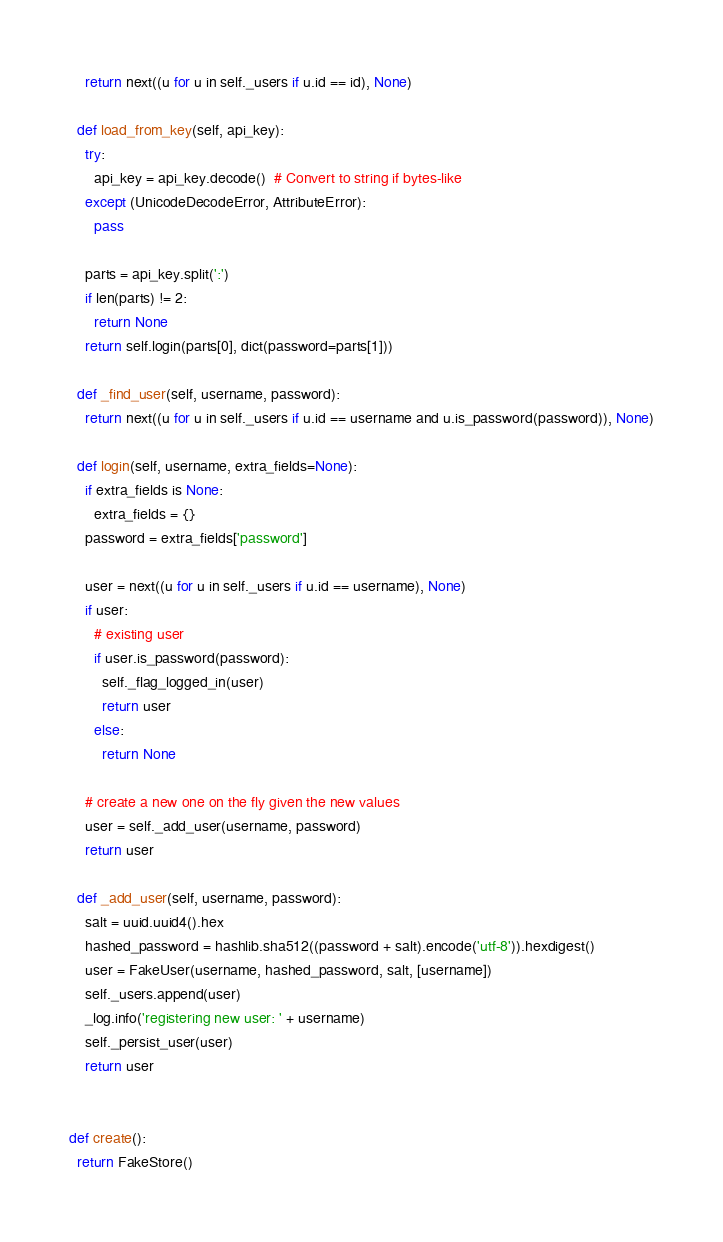<code> <loc_0><loc_0><loc_500><loc_500><_Python_>    return next((u for u in self._users if u.id == id), None)

  def load_from_key(self, api_key):
    try:
      api_key = api_key.decode()  # Convert to string if bytes-like
    except (UnicodeDecodeError, AttributeError):
      pass

    parts = api_key.split(':')
    if len(parts) != 2:
      return None
    return self.login(parts[0], dict(password=parts[1]))

  def _find_user(self, username, password):
    return next((u for u in self._users if u.id == username and u.is_password(password)), None)

  def login(self, username, extra_fields=None):
    if extra_fields is None:
      extra_fields = {}
    password = extra_fields['password']

    user = next((u for u in self._users if u.id == username), None)
    if user:
      # existing user
      if user.is_password(password):
        self._flag_logged_in(user)
        return user
      else:
        return None

    # create a new one on the fly given the new values
    user = self._add_user(username, password)
    return user

  def _add_user(self, username, password):
    salt = uuid.uuid4().hex
    hashed_password = hashlib.sha512((password + salt).encode('utf-8')).hexdigest()
    user = FakeUser(username, hashed_password, salt, [username])
    self._users.append(user)
    _log.info('registering new user: ' + username)
    self._persist_user(user)
    return user


def create():
  return FakeStore()
</code> 